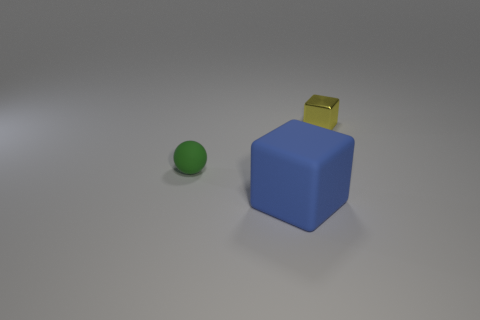There is a thing that is both on the left side of the yellow cube and on the right side of the small green object; what shape is it?
Your response must be concise. Cube. Are there any big blocks that are behind the tiny thing that is in front of the thing behind the small green rubber ball?
Offer a terse response. No. How many things are rubber things that are left of the large matte block or tiny things that are in front of the yellow thing?
Provide a succinct answer. 1. Is the material of the thing that is in front of the tiny rubber ball the same as the green ball?
Ensure brevity in your answer.  Yes. There is a thing that is both on the left side of the tiny shiny object and right of the small green rubber ball; what is its material?
Make the answer very short. Rubber. The small thing in front of the thing on the right side of the large matte object is what color?
Keep it short and to the point. Green. There is a tiny yellow thing that is the same shape as the big object; what is its material?
Provide a succinct answer. Metal. What color is the small thing on the right side of the rubber thing that is behind the block that is in front of the rubber sphere?
Provide a short and direct response. Yellow. How many objects are either small green spheres or blue objects?
Give a very brief answer. 2. How many small metallic things have the same shape as the large blue rubber thing?
Provide a short and direct response. 1. 